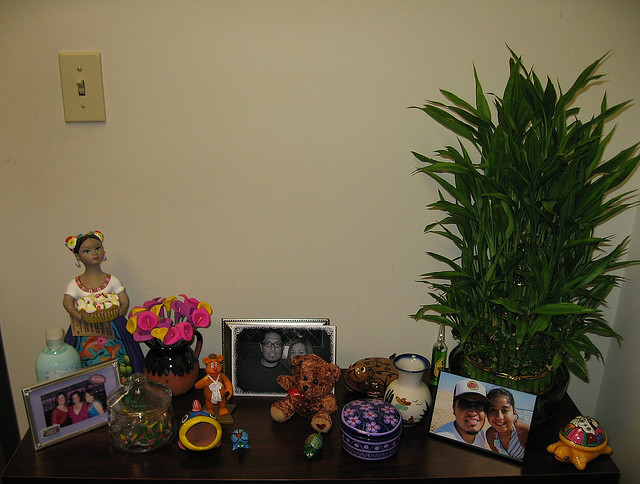<image>Where is the photo album? I don't know where the photo album is. It could be on the table, cabinet, desk, or nowhere visible in the image. Where is a baby picture? There is no baby picture in the image. What kind of plant is on the table? It is unknown what kind of plant is on the table. Some suggest it may be a bamboo or a fern. What manufacturer made the stuffed bear? It is unknown what manufacturer made the stuffed bear. It could be Hasbro, Gund, Boyds, Ty, Tyco, or Ikea. What holiday are these people getting ready to celebrate? It's ambiguous what holiday these people are getting ready to celebrate. It could be Christmas, Chinese New Year, or even a birthday. What color are the flowers? I am not sure what color the flowers are. They could be green, pink, or a combination of pink and yellow. Why do some photos have color and other do not? It is ambiguous why some photos have color and others do not. It might be due to personal preference, artistic esthetic, photographers' choice, or photo editing. What holiday does the center figurine represent? I am not sure which holiday the center figurine represents. It could represent either Christmas or Valentine's day. Where is the photo album? I don't know where the photo album is. It can be seen on the table or on the desk. Where is a baby picture? There is no baby picture in the image. What kind of plant is on the table? I am not sure what kind of plant is on the table. It can be bamboo, tree, or fern. What manufacturer made the stuffed bear? I don't know which manufacturer made the stuffed bear. It can be made by Hasbro, Gund, Boyds, Ty, Tyco, Ikea, or Gand. What color are the flowers? I don't know what color are the flowers. It can be green, pink or pink and yellow. Why do some photos have color and other do not? I don't know why some photos have color and others do not. It may be due to personal preference, artistic choice, or photo editing. What holiday does the center figurine represent? I don't know what holiday the center figurine represents. It can be either Christmas or Valentine's Day. What holiday are these people getting ready to celebrate? I don't know what holiday these people are getting ready to celebrate. It can be either Chinese New Year or Christmas. 